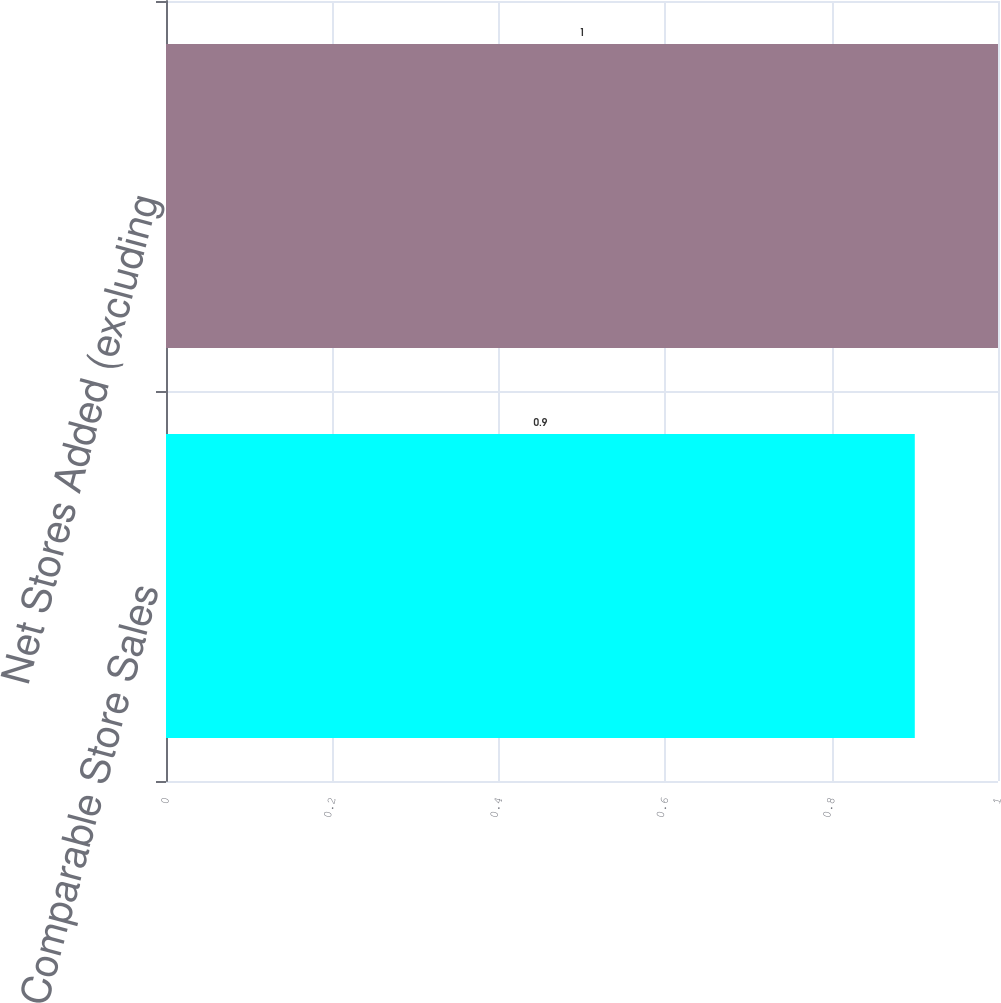Convert chart. <chart><loc_0><loc_0><loc_500><loc_500><bar_chart><fcel>Comparable Store Sales<fcel>Net Stores Added (excluding<nl><fcel>0.9<fcel>1<nl></chart> 